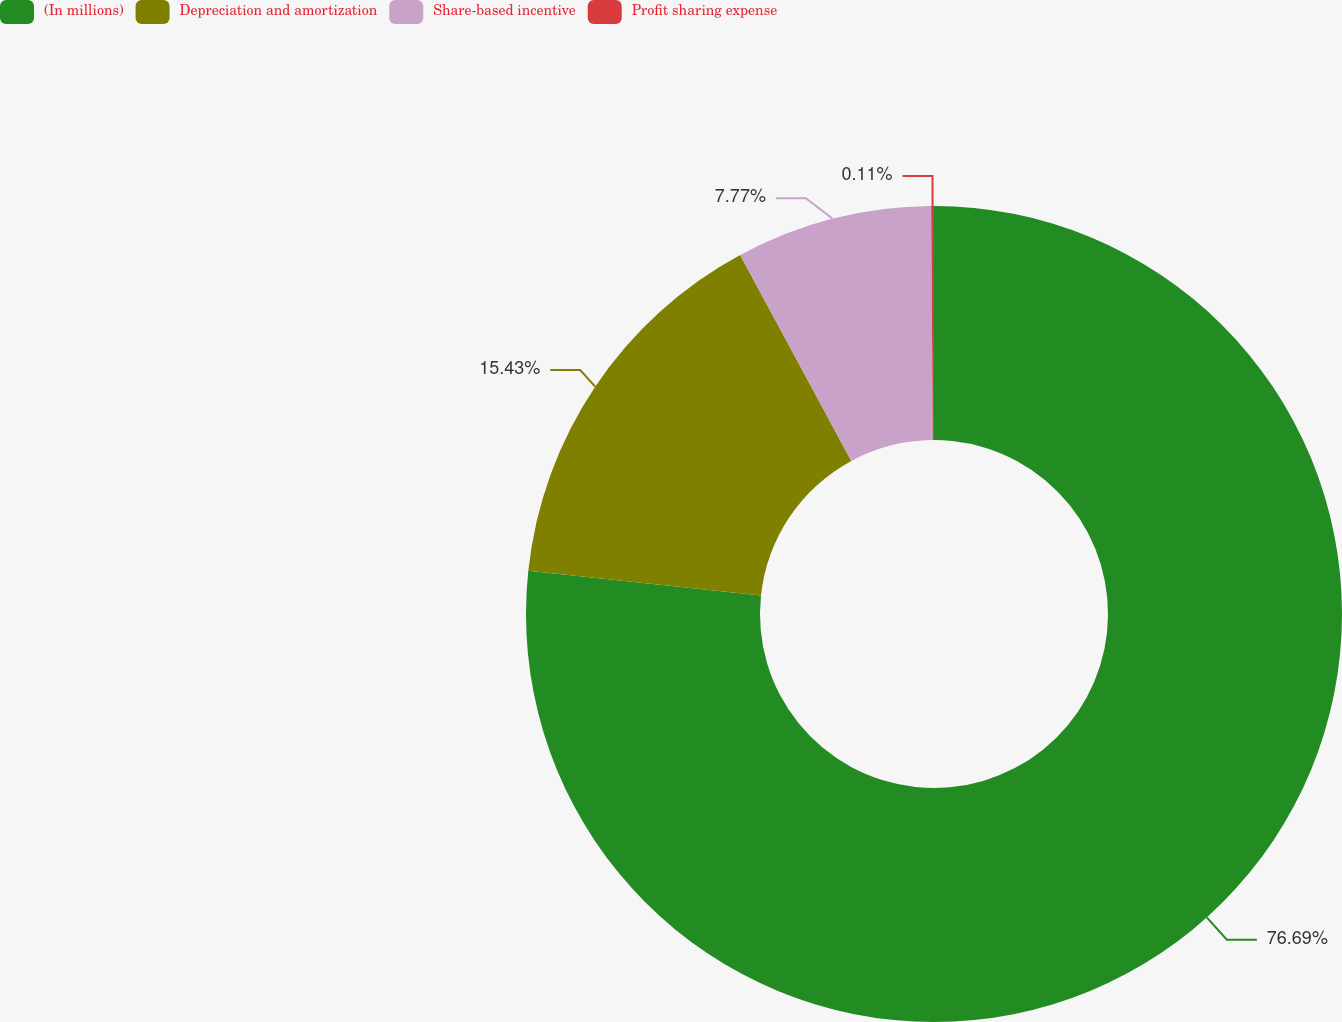<chart> <loc_0><loc_0><loc_500><loc_500><pie_chart><fcel>(In millions)<fcel>Depreciation and amortization<fcel>Share-based incentive<fcel>Profit sharing expense<nl><fcel>76.69%<fcel>15.43%<fcel>7.77%<fcel>0.11%<nl></chart> 